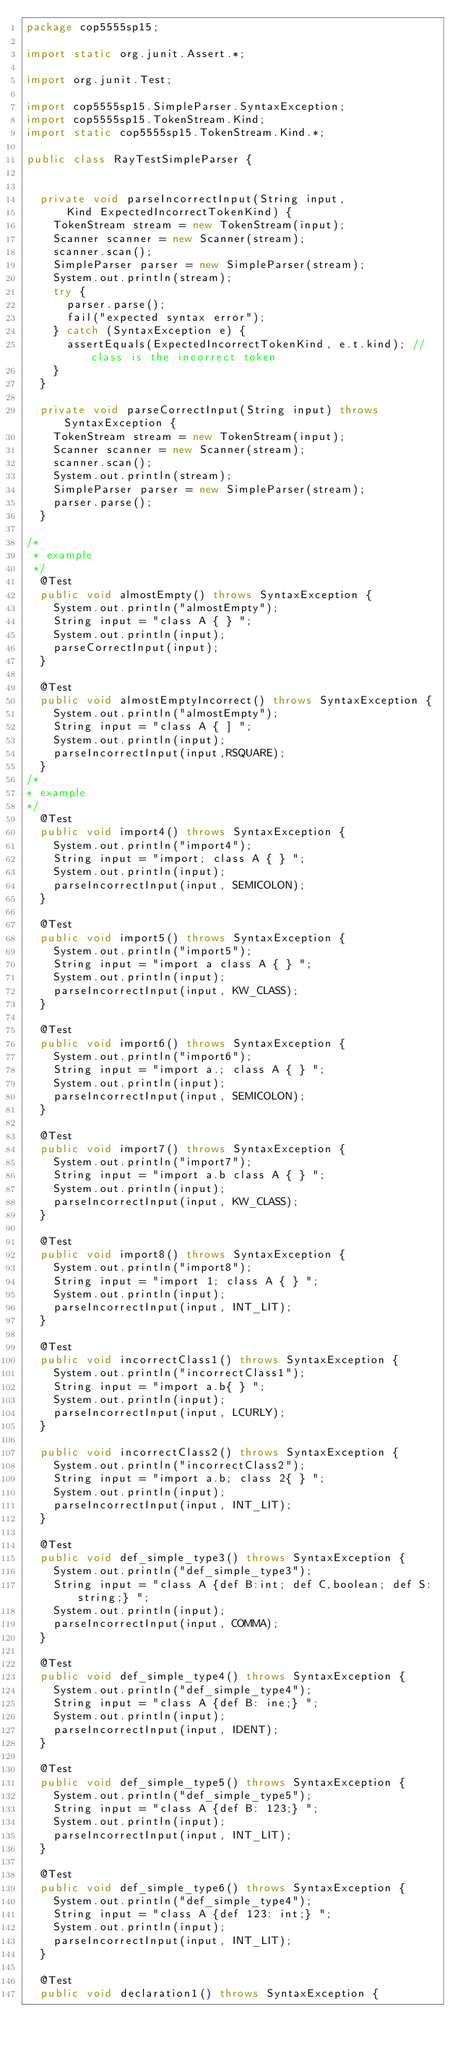Convert code to text. <code><loc_0><loc_0><loc_500><loc_500><_Java_>package cop5555sp15;

import static org.junit.Assert.*;

import org.junit.Test;

import cop5555sp15.SimpleParser.SyntaxException;
import cop5555sp15.TokenStream.Kind;
import static cop5555sp15.TokenStream.Kind.*;

public class RayTestSimpleParser {

	
	private void parseIncorrectInput(String input,
			Kind ExpectedIncorrectTokenKind) {
		TokenStream stream = new TokenStream(input);
		Scanner scanner = new Scanner(stream);
		scanner.scan();
		SimpleParser parser = new SimpleParser(stream);
		System.out.println(stream);
		try {
			parser.parse();
			fail("expected syntax error");
		} catch (SyntaxException e) {
			assertEquals(ExpectedIncorrectTokenKind, e.t.kind); // class is the incorrect token
		}
	}
	
	private void parseCorrectInput(String input) throws SyntaxException {
		TokenStream stream = new TokenStream(input);
		Scanner scanner = new Scanner(stream);
		scanner.scan();
		System.out.println(stream);
		SimpleParser parser = new SimpleParser(stream);
		parser.parse();
	}	
	
/*
 * example
 */
	@Test
	public void almostEmpty() throws SyntaxException {
		System.out.println("almostEmpty");
		String input = "class A { } ";
		System.out.println(input);
		parseCorrectInput(input);
	}
	
	@Test
	public void almostEmptyIncorrect() throws SyntaxException {
		System.out.println("almostEmpty");
		String input = "class A { ] ";
		System.out.println(input);
		parseIncorrectInput(input,RSQUARE);		
	}
/*
* example
*/
	@Test
	public void import4() throws SyntaxException {
		System.out.println("import4");
		String input = "import; class A { } ";
		System.out.println(input);
		parseIncorrectInput(input, SEMICOLON);	
	}
	
	@Test
	public void import5() throws SyntaxException {
		System.out.println("import5");
		String input = "import a class A { } ";
		System.out.println(input);
		parseIncorrectInput(input, KW_CLASS);	
	}
	
	@Test
	public void import6() throws SyntaxException {
		System.out.println("import6");
		String input = "import a.; class A { } ";
		System.out.println(input);
		parseIncorrectInput(input, SEMICOLON);	
	}
	
	@Test
	public void import7() throws SyntaxException {
		System.out.println("import7");
		String input = "import a.b class A { } ";
		System.out.println(input);
		parseIncorrectInput(input, KW_CLASS);	
	}
	
	@Test
	public void import8() throws SyntaxException {
		System.out.println("import8");
		String input = "import 1; class A { } ";
		System.out.println(input);
		parseIncorrectInput(input, INT_LIT);
	}
	
	@Test
	public void incorrectClass1() throws SyntaxException {
		System.out.println("incorrectClass1");
		String input = "import a.b{ } ";
		System.out.println(input);
		parseIncorrectInput(input, LCURLY);	
	}
	
	public void incorrectClass2() throws SyntaxException {
		System.out.println("incorrectClass2");
		String input = "import a.b; class 2{ } ";
		System.out.println(input);
		parseIncorrectInput(input, INT_LIT);	
	}
	
	@Test
	public void def_simple_type3() throws SyntaxException {
		System.out.println("def_simple_type3");
		String input = "class A {def B:int; def C,boolean; def S: string;} ";
		System.out.println(input);
		parseIncorrectInput(input, COMMA);	
	}
	
	@Test
	public void def_simple_type4() throws SyntaxException {
		System.out.println("def_simple_type4");
		String input = "class A {def B: ine;} ";
		System.out.println(input);
		parseIncorrectInput(input, IDENT);
	}
	
	@Test
	public void def_simple_type5() throws SyntaxException {
		System.out.println("def_simple_type5");
		String input = "class A {def B: 123;} ";
		System.out.println(input);
		parseIncorrectInput(input, INT_LIT);
	}
	
	@Test
	public void def_simple_type6() throws SyntaxException {
		System.out.println("def_simple_type4");
		String input = "class A {def 123: int;} ";
		System.out.println(input);
		parseIncorrectInput(input, INT_LIT);
	}
	
	@Test
	public void declaration1() throws SyntaxException {</code> 